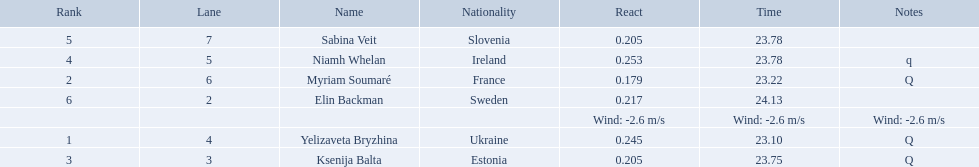What place did elin backman finish the race in? 6. How long did it take him to finish? 24.13. 